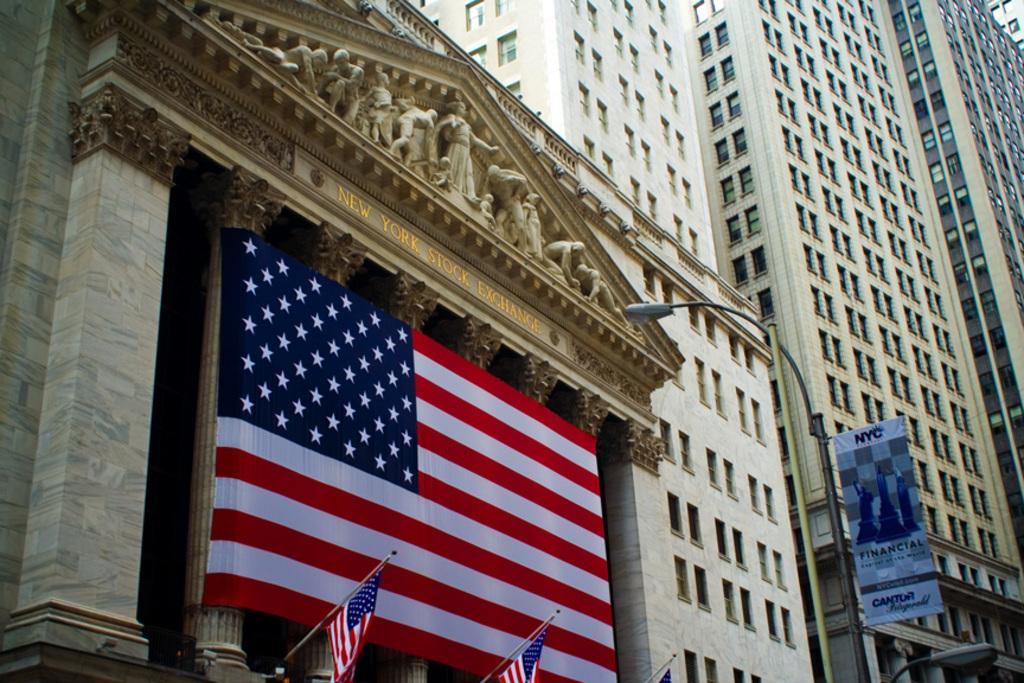What structures are present in the image? There are buildings in the image. Are there any additional features on the buildings? Yes, the buildings have flags on them. What type of haircut is the building getting in the image? There is no haircut being performed on the building in the image, as buildings do not have hair. 